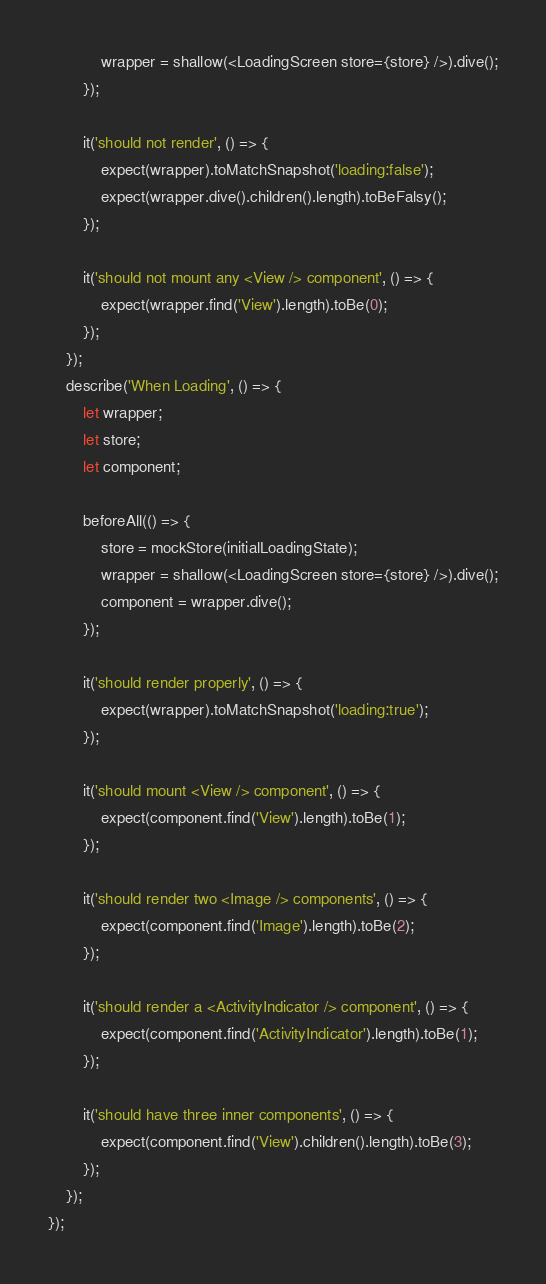Convert code to text. <code><loc_0><loc_0><loc_500><loc_500><_JavaScript_>			wrapper = shallow(<LoadingScreen store={store} />).dive();
		});

		it('should not render', () => {
			expect(wrapper).toMatchSnapshot('loading:false');
			expect(wrapper.dive().children().length).toBeFalsy();
		});

		it('should not mount any <View /> component', () => {
			expect(wrapper.find('View').length).toBe(0);
		});
	});
	describe('When Loading', () => {
		let wrapper;
		let store;
		let component;

		beforeAll(() => {
			store = mockStore(initialLoadingState);
			wrapper = shallow(<LoadingScreen store={store} />).dive();
			component = wrapper.dive();
		});

		it('should render properly', () => {
			expect(wrapper).toMatchSnapshot('loading:true');
		});

		it('should mount <View /> component', () => {
			expect(component.find('View').length).toBe(1);
		});

		it('should render two <Image /> components', () => {
			expect(component.find('Image').length).toBe(2);
		});

		it('should render a <ActivityIndicator /> component', () => {
			expect(component.find('ActivityIndicator').length).toBe(1);
		});

		it('should have three inner components', () => {
			expect(component.find('View').children().length).toBe(3);
		});
	});
});
</code> 